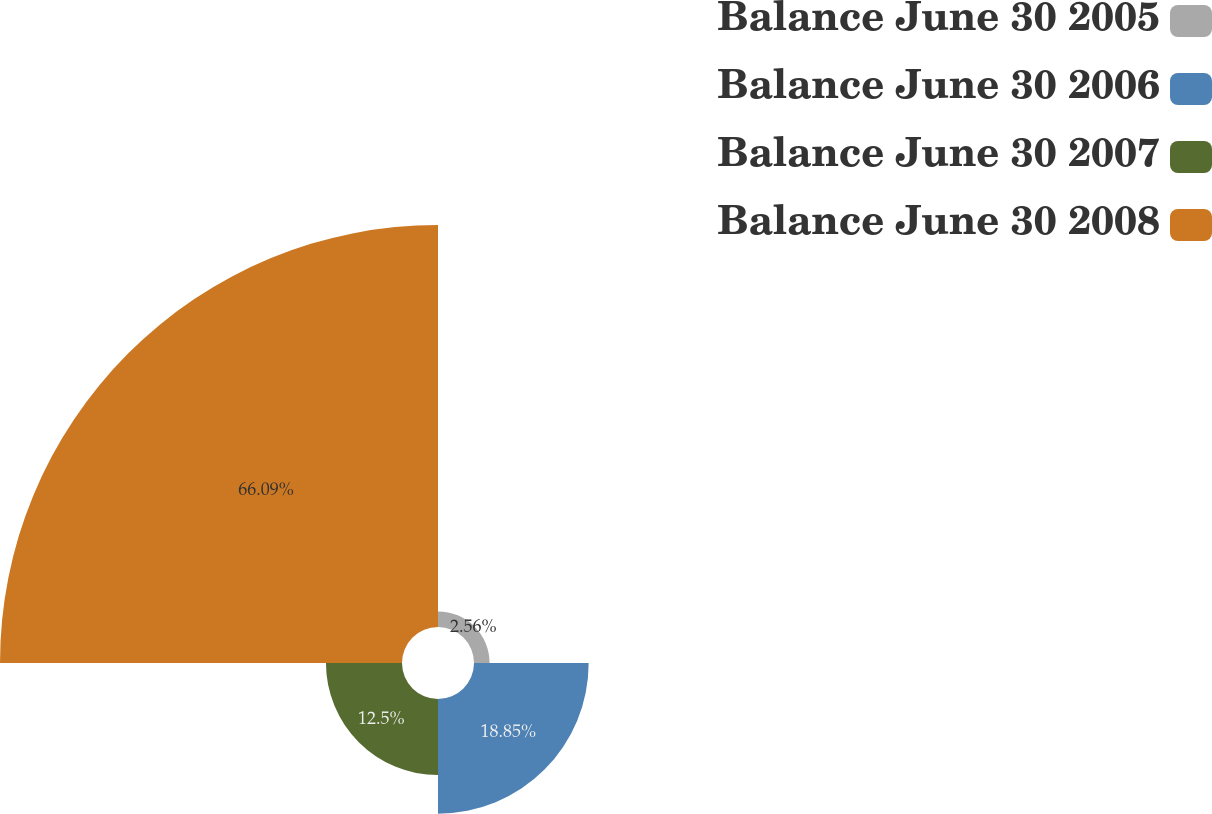Convert chart. <chart><loc_0><loc_0><loc_500><loc_500><pie_chart><fcel>Balance June 30 2005<fcel>Balance June 30 2006<fcel>Balance June 30 2007<fcel>Balance June 30 2008<nl><fcel>2.56%<fcel>18.85%<fcel>12.5%<fcel>66.09%<nl></chart> 